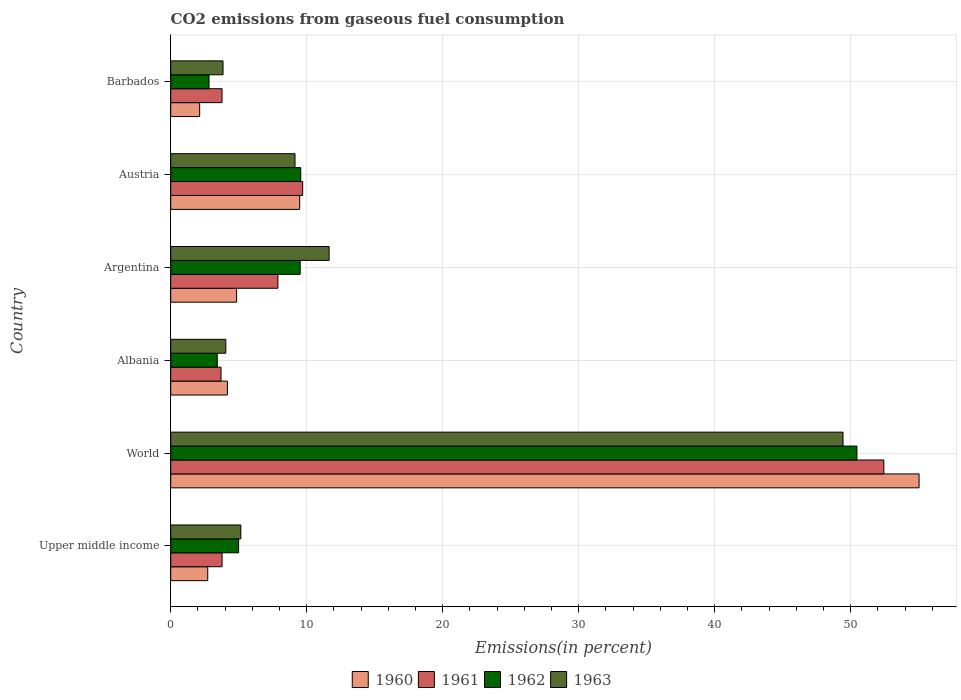How many different coloured bars are there?
Your answer should be compact. 4. Are the number of bars per tick equal to the number of legend labels?
Your response must be concise. Yes. Are the number of bars on each tick of the Y-axis equal?
Provide a succinct answer. Yes. What is the label of the 4th group of bars from the top?
Ensure brevity in your answer.  Albania. What is the total CO2 emitted in 1962 in World?
Provide a short and direct response. 50.46. Across all countries, what is the maximum total CO2 emitted in 1962?
Your answer should be compact. 50.46. Across all countries, what is the minimum total CO2 emitted in 1963?
Offer a very short reply. 3.85. In which country was the total CO2 emitted in 1961 maximum?
Provide a succinct answer. World. In which country was the total CO2 emitted in 1962 minimum?
Offer a terse response. Barbados. What is the total total CO2 emitted in 1960 in the graph?
Provide a short and direct response. 78.37. What is the difference between the total CO2 emitted in 1962 in Austria and that in Barbados?
Your answer should be very brief. 6.74. What is the difference between the total CO2 emitted in 1961 in World and the total CO2 emitted in 1962 in Upper middle income?
Give a very brief answer. 47.44. What is the average total CO2 emitted in 1961 per country?
Your response must be concise. 13.54. What is the difference between the total CO2 emitted in 1961 and total CO2 emitted in 1963 in Albania?
Provide a short and direct response. -0.35. What is the ratio of the total CO2 emitted in 1962 in Albania to that in Austria?
Provide a short and direct response. 0.36. Is the difference between the total CO2 emitted in 1961 in Albania and Argentina greater than the difference between the total CO2 emitted in 1963 in Albania and Argentina?
Your response must be concise. Yes. What is the difference between the highest and the second highest total CO2 emitted in 1961?
Provide a succinct answer. 42.73. What is the difference between the highest and the lowest total CO2 emitted in 1961?
Your response must be concise. 48.74. In how many countries, is the total CO2 emitted in 1960 greater than the average total CO2 emitted in 1960 taken over all countries?
Ensure brevity in your answer.  1. What does the 4th bar from the bottom in Upper middle income represents?
Ensure brevity in your answer.  1963. Does the graph contain grids?
Keep it short and to the point. Yes. What is the title of the graph?
Provide a short and direct response. CO2 emissions from gaseous fuel consumption. What is the label or title of the X-axis?
Provide a succinct answer. Emissions(in percent). What is the label or title of the Y-axis?
Your answer should be very brief. Country. What is the Emissions(in percent) in 1960 in Upper middle income?
Your response must be concise. 2.72. What is the Emissions(in percent) of 1961 in Upper middle income?
Ensure brevity in your answer.  3.78. What is the Emissions(in percent) in 1962 in Upper middle income?
Ensure brevity in your answer.  4.99. What is the Emissions(in percent) of 1963 in Upper middle income?
Provide a succinct answer. 5.15. What is the Emissions(in percent) in 1960 in World?
Offer a terse response. 55.02. What is the Emissions(in percent) in 1961 in World?
Your answer should be compact. 52.43. What is the Emissions(in percent) in 1962 in World?
Keep it short and to the point. 50.46. What is the Emissions(in percent) in 1963 in World?
Make the answer very short. 49.43. What is the Emissions(in percent) in 1960 in Albania?
Make the answer very short. 4.17. What is the Emissions(in percent) of 1961 in Albania?
Ensure brevity in your answer.  3.7. What is the Emissions(in percent) in 1962 in Albania?
Offer a terse response. 3.42. What is the Emissions(in percent) in 1963 in Albania?
Your response must be concise. 4.05. What is the Emissions(in percent) in 1960 in Argentina?
Provide a short and direct response. 4.85. What is the Emissions(in percent) of 1961 in Argentina?
Your response must be concise. 7.88. What is the Emissions(in percent) in 1962 in Argentina?
Offer a very short reply. 9.52. What is the Emissions(in percent) of 1963 in Argentina?
Your answer should be very brief. 11.65. What is the Emissions(in percent) of 1960 in Austria?
Provide a short and direct response. 9.48. What is the Emissions(in percent) of 1961 in Austria?
Your response must be concise. 9.7. What is the Emissions(in percent) in 1962 in Austria?
Provide a short and direct response. 9.56. What is the Emissions(in percent) in 1963 in Austria?
Provide a succinct answer. 9.14. What is the Emissions(in percent) of 1960 in Barbados?
Your answer should be compact. 2.13. What is the Emissions(in percent) in 1961 in Barbados?
Keep it short and to the point. 3.77. What is the Emissions(in percent) of 1962 in Barbados?
Provide a short and direct response. 2.82. What is the Emissions(in percent) of 1963 in Barbados?
Your response must be concise. 3.85. Across all countries, what is the maximum Emissions(in percent) in 1960?
Offer a terse response. 55.02. Across all countries, what is the maximum Emissions(in percent) of 1961?
Offer a very short reply. 52.43. Across all countries, what is the maximum Emissions(in percent) in 1962?
Provide a succinct answer. 50.46. Across all countries, what is the maximum Emissions(in percent) in 1963?
Give a very brief answer. 49.43. Across all countries, what is the minimum Emissions(in percent) of 1960?
Make the answer very short. 2.13. Across all countries, what is the minimum Emissions(in percent) in 1961?
Offer a very short reply. 3.7. Across all countries, what is the minimum Emissions(in percent) in 1962?
Your response must be concise. 2.82. Across all countries, what is the minimum Emissions(in percent) in 1963?
Give a very brief answer. 3.85. What is the total Emissions(in percent) in 1960 in the graph?
Keep it short and to the point. 78.37. What is the total Emissions(in percent) of 1961 in the graph?
Offer a terse response. 81.27. What is the total Emissions(in percent) in 1962 in the graph?
Give a very brief answer. 80.77. What is the total Emissions(in percent) of 1963 in the graph?
Make the answer very short. 83.27. What is the difference between the Emissions(in percent) of 1960 in Upper middle income and that in World?
Give a very brief answer. -52.3. What is the difference between the Emissions(in percent) of 1961 in Upper middle income and that in World?
Provide a succinct answer. -48.66. What is the difference between the Emissions(in percent) of 1962 in Upper middle income and that in World?
Provide a short and direct response. -45.46. What is the difference between the Emissions(in percent) in 1963 in Upper middle income and that in World?
Keep it short and to the point. -44.28. What is the difference between the Emissions(in percent) of 1960 in Upper middle income and that in Albania?
Provide a short and direct response. -1.44. What is the difference between the Emissions(in percent) in 1961 in Upper middle income and that in Albania?
Offer a terse response. 0.08. What is the difference between the Emissions(in percent) in 1962 in Upper middle income and that in Albania?
Your answer should be compact. 1.57. What is the difference between the Emissions(in percent) in 1963 in Upper middle income and that in Albania?
Your answer should be very brief. 1.11. What is the difference between the Emissions(in percent) of 1960 in Upper middle income and that in Argentina?
Offer a terse response. -2.12. What is the difference between the Emissions(in percent) in 1961 in Upper middle income and that in Argentina?
Ensure brevity in your answer.  -4.1. What is the difference between the Emissions(in percent) in 1962 in Upper middle income and that in Argentina?
Offer a very short reply. -4.53. What is the difference between the Emissions(in percent) of 1963 in Upper middle income and that in Argentina?
Provide a short and direct response. -6.49. What is the difference between the Emissions(in percent) in 1960 in Upper middle income and that in Austria?
Provide a short and direct response. -6.76. What is the difference between the Emissions(in percent) of 1961 in Upper middle income and that in Austria?
Offer a terse response. -5.92. What is the difference between the Emissions(in percent) of 1962 in Upper middle income and that in Austria?
Ensure brevity in your answer.  -4.57. What is the difference between the Emissions(in percent) in 1963 in Upper middle income and that in Austria?
Offer a terse response. -3.98. What is the difference between the Emissions(in percent) of 1960 in Upper middle income and that in Barbados?
Offer a terse response. 0.59. What is the difference between the Emissions(in percent) of 1961 in Upper middle income and that in Barbados?
Offer a very short reply. 0. What is the difference between the Emissions(in percent) in 1962 in Upper middle income and that in Barbados?
Provide a succinct answer. 2.18. What is the difference between the Emissions(in percent) in 1963 in Upper middle income and that in Barbados?
Your answer should be compact. 1.31. What is the difference between the Emissions(in percent) of 1960 in World and that in Albania?
Offer a terse response. 50.86. What is the difference between the Emissions(in percent) in 1961 in World and that in Albania?
Provide a succinct answer. 48.74. What is the difference between the Emissions(in percent) in 1962 in World and that in Albania?
Provide a short and direct response. 47.03. What is the difference between the Emissions(in percent) of 1963 in World and that in Albania?
Provide a short and direct response. 45.38. What is the difference between the Emissions(in percent) of 1960 in World and that in Argentina?
Ensure brevity in your answer.  50.18. What is the difference between the Emissions(in percent) of 1961 in World and that in Argentina?
Ensure brevity in your answer.  44.55. What is the difference between the Emissions(in percent) of 1962 in World and that in Argentina?
Your answer should be very brief. 40.94. What is the difference between the Emissions(in percent) in 1963 in World and that in Argentina?
Provide a succinct answer. 37.78. What is the difference between the Emissions(in percent) of 1960 in World and that in Austria?
Keep it short and to the point. 45.54. What is the difference between the Emissions(in percent) of 1961 in World and that in Austria?
Give a very brief answer. 42.73. What is the difference between the Emissions(in percent) in 1962 in World and that in Austria?
Give a very brief answer. 40.89. What is the difference between the Emissions(in percent) of 1963 in World and that in Austria?
Ensure brevity in your answer.  40.29. What is the difference between the Emissions(in percent) of 1960 in World and that in Barbados?
Provide a succinct answer. 52.9. What is the difference between the Emissions(in percent) in 1961 in World and that in Barbados?
Provide a short and direct response. 48.66. What is the difference between the Emissions(in percent) in 1962 in World and that in Barbados?
Give a very brief answer. 47.64. What is the difference between the Emissions(in percent) of 1963 in World and that in Barbados?
Your response must be concise. 45.59. What is the difference between the Emissions(in percent) in 1960 in Albania and that in Argentina?
Keep it short and to the point. -0.68. What is the difference between the Emissions(in percent) of 1961 in Albania and that in Argentina?
Provide a succinct answer. -4.18. What is the difference between the Emissions(in percent) in 1962 in Albania and that in Argentina?
Your answer should be compact. -6.1. What is the difference between the Emissions(in percent) of 1963 in Albania and that in Argentina?
Provide a short and direct response. -7.6. What is the difference between the Emissions(in percent) of 1960 in Albania and that in Austria?
Ensure brevity in your answer.  -5.32. What is the difference between the Emissions(in percent) in 1961 in Albania and that in Austria?
Ensure brevity in your answer.  -6. What is the difference between the Emissions(in percent) of 1962 in Albania and that in Austria?
Offer a very short reply. -6.14. What is the difference between the Emissions(in percent) of 1963 in Albania and that in Austria?
Provide a succinct answer. -5.09. What is the difference between the Emissions(in percent) in 1960 in Albania and that in Barbados?
Your answer should be compact. 2.04. What is the difference between the Emissions(in percent) of 1961 in Albania and that in Barbados?
Make the answer very short. -0.08. What is the difference between the Emissions(in percent) of 1962 in Albania and that in Barbados?
Your answer should be very brief. 0.61. What is the difference between the Emissions(in percent) of 1963 in Albania and that in Barbados?
Make the answer very short. 0.2. What is the difference between the Emissions(in percent) in 1960 in Argentina and that in Austria?
Offer a terse response. -4.64. What is the difference between the Emissions(in percent) of 1961 in Argentina and that in Austria?
Ensure brevity in your answer.  -1.82. What is the difference between the Emissions(in percent) of 1962 in Argentina and that in Austria?
Your answer should be very brief. -0.04. What is the difference between the Emissions(in percent) of 1963 in Argentina and that in Austria?
Your response must be concise. 2.51. What is the difference between the Emissions(in percent) in 1960 in Argentina and that in Barbados?
Make the answer very short. 2.72. What is the difference between the Emissions(in percent) of 1961 in Argentina and that in Barbados?
Keep it short and to the point. 4.11. What is the difference between the Emissions(in percent) of 1962 in Argentina and that in Barbados?
Give a very brief answer. 6.7. What is the difference between the Emissions(in percent) in 1963 in Argentina and that in Barbados?
Offer a terse response. 7.8. What is the difference between the Emissions(in percent) in 1960 in Austria and that in Barbados?
Offer a terse response. 7.35. What is the difference between the Emissions(in percent) of 1961 in Austria and that in Barbados?
Your response must be concise. 5.93. What is the difference between the Emissions(in percent) in 1962 in Austria and that in Barbados?
Make the answer very short. 6.74. What is the difference between the Emissions(in percent) of 1963 in Austria and that in Barbados?
Give a very brief answer. 5.29. What is the difference between the Emissions(in percent) of 1960 in Upper middle income and the Emissions(in percent) of 1961 in World?
Ensure brevity in your answer.  -49.71. What is the difference between the Emissions(in percent) in 1960 in Upper middle income and the Emissions(in percent) in 1962 in World?
Make the answer very short. -47.73. What is the difference between the Emissions(in percent) in 1960 in Upper middle income and the Emissions(in percent) in 1963 in World?
Your response must be concise. -46.71. What is the difference between the Emissions(in percent) of 1961 in Upper middle income and the Emissions(in percent) of 1962 in World?
Provide a succinct answer. -46.68. What is the difference between the Emissions(in percent) in 1961 in Upper middle income and the Emissions(in percent) in 1963 in World?
Your response must be concise. -45.66. What is the difference between the Emissions(in percent) of 1962 in Upper middle income and the Emissions(in percent) of 1963 in World?
Keep it short and to the point. -44.44. What is the difference between the Emissions(in percent) in 1960 in Upper middle income and the Emissions(in percent) in 1961 in Albania?
Ensure brevity in your answer.  -0.98. What is the difference between the Emissions(in percent) in 1960 in Upper middle income and the Emissions(in percent) in 1962 in Albania?
Make the answer very short. -0.7. What is the difference between the Emissions(in percent) in 1960 in Upper middle income and the Emissions(in percent) in 1963 in Albania?
Give a very brief answer. -1.33. What is the difference between the Emissions(in percent) of 1961 in Upper middle income and the Emissions(in percent) of 1962 in Albania?
Your answer should be very brief. 0.35. What is the difference between the Emissions(in percent) in 1961 in Upper middle income and the Emissions(in percent) in 1963 in Albania?
Ensure brevity in your answer.  -0.27. What is the difference between the Emissions(in percent) in 1962 in Upper middle income and the Emissions(in percent) in 1963 in Albania?
Keep it short and to the point. 0.94. What is the difference between the Emissions(in percent) in 1960 in Upper middle income and the Emissions(in percent) in 1961 in Argentina?
Your answer should be very brief. -5.16. What is the difference between the Emissions(in percent) in 1960 in Upper middle income and the Emissions(in percent) in 1962 in Argentina?
Provide a succinct answer. -6.8. What is the difference between the Emissions(in percent) in 1960 in Upper middle income and the Emissions(in percent) in 1963 in Argentina?
Your answer should be compact. -8.93. What is the difference between the Emissions(in percent) of 1961 in Upper middle income and the Emissions(in percent) of 1962 in Argentina?
Offer a very short reply. -5.74. What is the difference between the Emissions(in percent) in 1961 in Upper middle income and the Emissions(in percent) in 1963 in Argentina?
Offer a terse response. -7.87. What is the difference between the Emissions(in percent) in 1962 in Upper middle income and the Emissions(in percent) in 1963 in Argentina?
Provide a succinct answer. -6.66. What is the difference between the Emissions(in percent) in 1960 in Upper middle income and the Emissions(in percent) in 1961 in Austria?
Your response must be concise. -6.98. What is the difference between the Emissions(in percent) of 1960 in Upper middle income and the Emissions(in percent) of 1962 in Austria?
Offer a terse response. -6.84. What is the difference between the Emissions(in percent) in 1960 in Upper middle income and the Emissions(in percent) in 1963 in Austria?
Your answer should be very brief. -6.42. What is the difference between the Emissions(in percent) in 1961 in Upper middle income and the Emissions(in percent) in 1962 in Austria?
Give a very brief answer. -5.78. What is the difference between the Emissions(in percent) of 1961 in Upper middle income and the Emissions(in percent) of 1963 in Austria?
Your answer should be compact. -5.36. What is the difference between the Emissions(in percent) of 1962 in Upper middle income and the Emissions(in percent) of 1963 in Austria?
Provide a succinct answer. -4.15. What is the difference between the Emissions(in percent) of 1960 in Upper middle income and the Emissions(in percent) of 1961 in Barbados?
Your answer should be compact. -1.05. What is the difference between the Emissions(in percent) in 1960 in Upper middle income and the Emissions(in percent) in 1962 in Barbados?
Offer a very short reply. -0.1. What is the difference between the Emissions(in percent) of 1960 in Upper middle income and the Emissions(in percent) of 1963 in Barbados?
Provide a short and direct response. -1.12. What is the difference between the Emissions(in percent) of 1961 in Upper middle income and the Emissions(in percent) of 1962 in Barbados?
Ensure brevity in your answer.  0.96. What is the difference between the Emissions(in percent) of 1961 in Upper middle income and the Emissions(in percent) of 1963 in Barbados?
Make the answer very short. -0.07. What is the difference between the Emissions(in percent) of 1962 in Upper middle income and the Emissions(in percent) of 1963 in Barbados?
Offer a terse response. 1.15. What is the difference between the Emissions(in percent) in 1960 in World and the Emissions(in percent) in 1961 in Albania?
Offer a very short reply. 51.33. What is the difference between the Emissions(in percent) in 1960 in World and the Emissions(in percent) in 1962 in Albania?
Provide a succinct answer. 51.6. What is the difference between the Emissions(in percent) of 1960 in World and the Emissions(in percent) of 1963 in Albania?
Offer a very short reply. 50.98. What is the difference between the Emissions(in percent) of 1961 in World and the Emissions(in percent) of 1962 in Albania?
Keep it short and to the point. 49.01. What is the difference between the Emissions(in percent) of 1961 in World and the Emissions(in percent) of 1963 in Albania?
Ensure brevity in your answer.  48.38. What is the difference between the Emissions(in percent) of 1962 in World and the Emissions(in percent) of 1963 in Albania?
Keep it short and to the point. 46.41. What is the difference between the Emissions(in percent) of 1960 in World and the Emissions(in percent) of 1961 in Argentina?
Provide a succinct answer. 47.14. What is the difference between the Emissions(in percent) in 1960 in World and the Emissions(in percent) in 1962 in Argentina?
Your answer should be very brief. 45.5. What is the difference between the Emissions(in percent) of 1960 in World and the Emissions(in percent) of 1963 in Argentina?
Your answer should be very brief. 43.38. What is the difference between the Emissions(in percent) of 1961 in World and the Emissions(in percent) of 1962 in Argentina?
Keep it short and to the point. 42.91. What is the difference between the Emissions(in percent) in 1961 in World and the Emissions(in percent) in 1963 in Argentina?
Ensure brevity in your answer.  40.78. What is the difference between the Emissions(in percent) of 1962 in World and the Emissions(in percent) of 1963 in Argentina?
Offer a terse response. 38.81. What is the difference between the Emissions(in percent) in 1960 in World and the Emissions(in percent) in 1961 in Austria?
Ensure brevity in your answer.  45.32. What is the difference between the Emissions(in percent) of 1960 in World and the Emissions(in percent) of 1962 in Austria?
Provide a succinct answer. 45.46. What is the difference between the Emissions(in percent) of 1960 in World and the Emissions(in percent) of 1963 in Austria?
Give a very brief answer. 45.88. What is the difference between the Emissions(in percent) in 1961 in World and the Emissions(in percent) in 1962 in Austria?
Provide a succinct answer. 42.87. What is the difference between the Emissions(in percent) of 1961 in World and the Emissions(in percent) of 1963 in Austria?
Give a very brief answer. 43.29. What is the difference between the Emissions(in percent) of 1962 in World and the Emissions(in percent) of 1963 in Austria?
Provide a succinct answer. 41.32. What is the difference between the Emissions(in percent) in 1960 in World and the Emissions(in percent) in 1961 in Barbados?
Give a very brief answer. 51.25. What is the difference between the Emissions(in percent) of 1960 in World and the Emissions(in percent) of 1962 in Barbados?
Your answer should be compact. 52.21. What is the difference between the Emissions(in percent) of 1960 in World and the Emissions(in percent) of 1963 in Barbados?
Provide a succinct answer. 51.18. What is the difference between the Emissions(in percent) in 1961 in World and the Emissions(in percent) in 1962 in Barbados?
Give a very brief answer. 49.62. What is the difference between the Emissions(in percent) of 1961 in World and the Emissions(in percent) of 1963 in Barbados?
Give a very brief answer. 48.59. What is the difference between the Emissions(in percent) of 1962 in World and the Emissions(in percent) of 1963 in Barbados?
Make the answer very short. 46.61. What is the difference between the Emissions(in percent) of 1960 in Albania and the Emissions(in percent) of 1961 in Argentina?
Your answer should be very brief. -3.71. What is the difference between the Emissions(in percent) in 1960 in Albania and the Emissions(in percent) in 1962 in Argentina?
Ensure brevity in your answer.  -5.35. What is the difference between the Emissions(in percent) of 1960 in Albania and the Emissions(in percent) of 1963 in Argentina?
Make the answer very short. -7.48. What is the difference between the Emissions(in percent) of 1961 in Albania and the Emissions(in percent) of 1962 in Argentina?
Give a very brief answer. -5.82. What is the difference between the Emissions(in percent) in 1961 in Albania and the Emissions(in percent) in 1963 in Argentina?
Provide a short and direct response. -7.95. What is the difference between the Emissions(in percent) in 1962 in Albania and the Emissions(in percent) in 1963 in Argentina?
Your response must be concise. -8.23. What is the difference between the Emissions(in percent) in 1960 in Albania and the Emissions(in percent) in 1961 in Austria?
Provide a succinct answer. -5.54. What is the difference between the Emissions(in percent) in 1960 in Albania and the Emissions(in percent) in 1962 in Austria?
Give a very brief answer. -5.39. What is the difference between the Emissions(in percent) of 1960 in Albania and the Emissions(in percent) of 1963 in Austria?
Give a very brief answer. -4.97. What is the difference between the Emissions(in percent) in 1961 in Albania and the Emissions(in percent) in 1962 in Austria?
Ensure brevity in your answer.  -5.86. What is the difference between the Emissions(in percent) of 1961 in Albania and the Emissions(in percent) of 1963 in Austria?
Provide a succinct answer. -5.44. What is the difference between the Emissions(in percent) of 1962 in Albania and the Emissions(in percent) of 1963 in Austria?
Keep it short and to the point. -5.72. What is the difference between the Emissions(in percent) of 1960 in Albania and the Emissions(in percent) of 1961 in Barbados?
Offer a terse response. 0.39. What is the difference between the Emissions(in percent) in 1960 in Albania and the Emissions(in percent) in 1962 in Barbados?
Keep it short and to the point. 1.35. What is the difference between the Emissions(in percent) of 1960 in Albania and the Emissions(in percent) of 1963 in Barbados?
Provide a short and direct response. 0.32. What is the difference between the Emissions(in percent) of 1961 in Albania and the Emissions(in percent) of 1962 in Barbados?
Offer a very short reply. 0.88. What is the difference between the Emissions(in percent) in 1961 in Albania and the Emissions(in percent) in 1963 in Barbados?
Offer a very short reply. -0.15. What is the difference between the Emissions(in percent) in 1962 in Albania and the Emissions(in percent) in 1963 in Barbados?
Give a very brief answer. -0.42. What is the difference between the Emissions(in percent) of 1960 in Argentina and the Emissions(in percent) of 1961 in Austria?
Your answer should be compact. -4.86. What is the difference between the Emissions(in percent) of 1960 in Argentina and the Emissions(in percent) of 1962 in Austria?
Your response must be concise. -4.72. What is the difference between the Emissions(in percent) of 1960 in Argentina and the Emissions(in percent) of 1963 in Austria?
Your response must be concise. -4.29. What is the difference between the Emissions(in percent) in 1961 in Argentina and the Emissions(in percent) in 1962 in Austria?
Offer a very short reply. -1.68. What is the difference between the Emissions(in percent) in 1961 in Argentina and the Emissions(in percent) in 1963 in Austria?
Your response must be concise. -1.26. What is the difference between the Emissions(in percent) in 1962 in Argentina and the Emissions(in percent) in 1963 in Austria?
Give a very brief answer. 0.38. What is the difference between the Emissions(in percent) of 1960 in Argentina and the Emissions(in percent) of 1961 in Barbados?
Give a very brief answer. 1.07. What is the difference between the Emissions(in percent) in 1960 in Argentina and the Emissions(in percent) in 1962 in Barbados?
Keep it short and to the point. 2.03. What is the difference between the Emissions(in percent) of 1961 in Argentina and the Emissions(in percent) of 1962 in Barbados?
Provide a short and direct response. 5.06. What is the difference between the Emissions(in percent) of 1961 in Argentina and the Emissions(in percent) of 1963 in Barbados?
Provide a short and direct response. 4.04. What is the difference between the Emissions(in percent) in 1962 in Argentina and the Emissions(in percent) in 1963 in Barbados?
Provide a short and direct response. 5.67. What is the difference between the Emissions(in percent) in 1960 in Austria and the Emissions(in percent) in 1961 in Barbados?
Provide a succinct answer. 5.71. What is the difference between the Emissions(in percent) of 1960 in Austria and the Emissions(in percent) of 1962 in Barbados?
Your answer should be very brief. 6.67. What is the difference between the Emissions(in percent) in 1960 in Austria and the Emissions(in percent) in 1963 in Barbados?
Offer a very short reply. 5.64. What is the difference between the Emissions(in percent) of 1961 in Austria and the Emissions(in percent) of 1962 in Barbados?
Your response must be concise. 6.88. What is the difference between the Emissions(in percent) of 1961 in Austria and the Emissions(in percent) of 1963 in Barbados?
Offer a terse response. 5.86. What is the difference between the Emissions(in percent) of 1962 in Austria and the Emissions(in percent) of 1963 in Barbados?
Your answer should be very brief. 5.71. What is the average Emissions(in percent) in 1960 per country?
Your response must be concise. 13.06. What is the average Emissions(in percent) of 1961 per country?
Keep it short and to the point. 13.54. What is the average Emissions(in percent) in 1962 per country?
Keep it short and to the point. 13.46. What is the average Emissions(in percent) of 1963 per country?
Provide a short and direct response. 13.88. What is the difference between the Emissions(in percent) in 1960 and Emissions(in percent) in 1961 in Upper middle income?
Make the answer very short. -1.06. What is the difference between the Emissions(in percent) in 1960 and Emissions(in percent) in 1962 in Upper middle income?
Offer a very short reply. -2.27. What is the difference between the Emissions(in percent) of 1960 and Emissions(in percent) of 1963 in Upper middle income?
Your answer should be compact. -2.43. What is the difference between the Emissions(in percent) in 1961 and Emissions(in percent) in 1962 in Upper middle income?
Your response must be concise. -1.22. What is the difference between the Emissions(in percent) in 1961 and Emissions(in percent) in 1963 in Upper middle income?
Keep it short and to the point. -1.38. What is the difference between the Emissions(in percent) in 1962 and Emissions(in percent) in 1963 in Upper middle income?
Your answer should be compact. -0.16. What is the difference between the Emissions(in percent) in 1960 and Emissions(in percent) in 1961 in World?
Your response must be concise. 2.59. What is the difference between the Emissions(in percent) in 1960 and Emissions(in percent) in 1962 in World?
Ensure brevity in your answer.  4.57. What is the difference between the Emissions(in percent) in 1960 and Emissions(in percent) in 1963 in World?
Offer a very short reply. 5.59. What is the difference between the Emissions(in percent) of 1961 and Emissions(in percent) of 1962 in World?
Ensure brevity in your answer.  1.98. What is the difference between the Emissions(in percent) of 1961 and Emissions(in percent) of 1963 in World?
Keep it short and to the point. 3. What is the difference between the Emissions(in percent) in 1962 and Emissions(in percent) in 1963 in World?
Keep it short and to the point. 1.02. What is the difference between the Emissions(in percent) in 1960 and Emissions(in percent) in 1961 in Albania?
Your answer should be compact. 0.47. What is the difference between the Emissions(in percent) of 1960 and Emissions(in percent) of 1962 in Albania?
Your answer should be compact. 0.74. What is the difference between the Emissions(in percent) in 1960 and Emissions(in percent) in 1963 in Albania?
Offer a very short reply. 0.12. What is the difference between the Emissions(in percent) of 1961 and Emissions(in percent) of 1962 in Albania?
Offer a terse response. 0.28. What is the difference between the Emissions(in percent) in 1961 and Emissions(in percent) in 1963 in Albania?
Make the answer very short. -0.35. What is the difference between the Emissions(in percent) of 1962 and Emissions(in percent) of 1963 in Albania?
Your answer should be compact. -0.63. What is the difference between the Emissions(in percent) in 1960 and Emissions(in percent) in 1961 in Argentina?
Offer a very short reply. -3.04. What is the difference between the Emissions(in percent) of 1960 and Emissions(in percent) of 1962 in Argentina?
Give a very brief answer. -4.67. What is the difference between the Emissions(in percent) in 1960 and Emissions(in percent) in 1963 in Argentina?
Ensure brevity in your answer.  -6.8. What is the difference between the Emissions(in percent) of 1961 and Emissions(in percent) of 1962 in Argentina?
Keep it short and to the point. -1.64. What is the difference between the Emissions(in percent) in 1961 and Emissions(in percent) in 1963 in Argentina?
Your answer should be compact. -3.77. What is the difference between the Emissions(in percent) of 1962 and Emissions(in percent) of 1963 in Argentina?
Offer a terse response. -2.13. What is the difference between the Emissions(in percent) in 1960 and Emissions(in percent) in 1961 in Austria?
Your answer should be very brief. -0.22. What is the difference between the Emissions(in percent) of 1960 and Emissions(in percent) of 1962 in Austria?
Keep it short and to the point. -0.08. What is the difference between the Emissions(in percent) of 1960 and Emissions(in percent) of 1963 in Austria?
Offer a very short reply. 0.34. What is the difference between the Emissions(in percent) in 1961 and Emissions(in percent) in 1962 in Austria?
Provide a short and direct response. 0.14. What is the difference between the Emissions(in percent) of 1961 and Emissions(in percent) of 1963 in Austria?
Keep it short and to the point. 0.56. What is the difference between the Emissions(in percent) of 1962 and Emissions(in percent) of 1963 in Austria?
Give a very brief answer. 0.42. What is the difference between the Emissions(in percent) in 1960 and Emissions(in percent) in 1961 in Barbados?
Offer a terse response. -1.65. What is the difference between the Emissions(in percent) in 1960 and Emissions(in percent) in 1962 in Barbados?
Offer a very short reply. -0.69. What is the difference between the Emissions(in percent) of 1960 and Emissions(in percent) of 1963 in Barbados?
Ensure brevity in your answer.  -1.72. What is the difference between the Emissions(in percent) in 1961 and Emissions(in percent) in 1962 in Barbados?
Provide a succinct answer. 0.96. What is the difference between the Emissions(in percent) of 1961 and Emissions(in percent) of 1963 in Barbados?
Provide a succinct answer. -0.07. What is the difference between the Emissions(in percent) in 1962 and Emissions(in percent) in 1963 in Barbados?
Offer a very short reply. -1.03. What is the ratio of the Emissions(in percent) in 1960 in Upper middle income to that in World?
Ensure brevity in your answer.  0.05. What is the ratio of the Emissions(in percent) in 1961 in Upper middle income to that in World?
Offer a very short reply. 0.07. What is the ratio of the Emissions(in percent) in 1962 in Upper middle income to that in World?
Your answer should be very brief. 0.1. What is the ratio of the Emissions(in percent) in 1963 in Upper middle income to that in World?
Make the answer very short. 0.1. What is the ratio of the Emissions(in percent) of 1960 in Upper middle income to that in Albania?
Offer a very short reply. 0.65. What is the ratio of the Emissions(in percent) in 1961 in Upper middle income to that in Albania?
Give a very brief answer. 1.02. What is the ratio of the Emissions(in percent) in 1962 in Upper middle income to that in Albania?
Offer a terse response. 1.46. What is the ratio of the Emissions(in percent) of 1963 in Upper middle income to that in Albania?
Ensure brevity in your answer.  1.27. What is the ratio of the Emissions(in percent) in 1960 in Upper middle income to that in Argentina?
Provide a short and direct response. 0.56. What is the ratio of the Emissions(in percent) in 1961 in Upper middle income to that in Argentina?
Offer a terse response. 0.48. What is the ratio of the Emissions(in percent) in 1962 in Upper middle income to that in Argentina?
Keep it short and to the point. 0.52. What is the ratio of the Emissions(in percent) of 1963 in Upper middle income to that in Argentina?
Offer a very short reply. 0.44. What is the ratio of the Emissions(in percent) of 1960 in Upper middle income to that in Austria?
Keep it short and to the point. 0.29. What is the ratio of the Emissions(in percent) in 1961 in Upper middle income to that in Austria?
Your answer should be compact. 0.39. What is the ratio of the Emissions(in percent) of 1962 in Upper middle income to that in Austria?
Keep it short and to the point. 0.52. What is the ratio of the Emissions(in percent) in 1963 in Upper middle income to that in Austria?
Offer a terse response. 0.56. What is the ratio of the Emissions(in percent) in 1960 in Upper middle income to that in Barbados?
Make the answer very short. 1.28. What is the ratio of the Emissions(in percent) of 1962 in Upper middle income to that in Barbados?
Your answer should be very brief. 1.77. What is the ratio of the Emissions(in percent) in 1963 in Upper middle income to that in Barbados?
Give a very brief answer. 1.34. What is the ratio of the Emissions(in percent) in 1960 in World to that in Albania?
Offer a very short reply. 13.21. What is the ratio of the Emissions(in percent) in 1961 in World to that in Albania?
Keep it short and to the point. 14.18. What is the ratio of the Emissions(in percent) in 1962 in World to that in Albania?
Your answer should be compact. 14.74. What is the ratio of the Emissions(in percent) in 1963 in World to that in Albania?
Ensure brevity in your answer.  12.21. What is the ratio of the Emissions(in percent) of 1960 in World to that in Argentina?
Your answer should be compact. 11.36. What is the ratio of the Emissions(in percent) in 1961 in World to that in Argentina?
Keep it short and to the point. 6.65. What is the ratio of the Emissions(in percent) in 1962 in World to that in Argentina?
Provide a succinct answer. 5.3. What is the ratio of the Emissions(in percent) in 1963 in World to that in Argentina?
Give a very brief answer. 4.24. What is the ratio of the Emissions(in percent) of 1960 in World to that in Austria?
Provide a short and direct response. 5.8. What is the ratio of the Emissions(in percent) of 1961 in World to that in Austria?
Provide a short and direct response. 5.4. What is the ratio of the Emissions(in percent) in 1962 in World to that in Austria?
Ensure brevity in your answer.  5.28. What is the ratio of the Emissions(in percent) of 1963 in World to that in Austria?
Provide a short and direct response. 5.41. What is the ratio of the Emissions(in percent) of 1960 in World to that in Barbados?
Your answer should be very brief. 25.86. What is the ratio of the Emissions(in percent) in 1961 in World to that in Barbados?
Your response must be concise. 13.89. What is the ratio of the Emissions(in percent) of 1962 in World to that in Barbados?
Your answer should be compact. 17.91. What is the ratio of the Emissions(in percent) in 1963 in World to that in Barbados?
Give a very brief answer. 12.85. What is the ratio of the Emissions(in percent) in 1960 in Albania to that in Argentina?
Offer a terse response. 0.86. What is the ratio of the Emissions(in percent) in 1961 in Albania to that in Argentina?
Keep it short and to the point. 0.47. What is the ratio of the Emissions(in percent) of 1962 in Albania to that in Argentina?
Your answer should be very brief. 0.36. What is the ratio of the Emissions(in percent) of 1963 in Albania to that in Argentina?
Your answer should be compact. 0.35. What is the ratio of the Emissions(in percent) in 1960 in Albania to that in Austria?
Your answer should be compact. 0.44. What is the ratio of the Emissions(in percent) of 1961 in Albania to that in Austria?
Give a very brief answer. 0.38. What is the ratio of the Emissions(in percent) of 1962 in Albania to that in Austria?
Offer a very short reply. 0.36. What is the ratio of the Emissions(in percent) in 1963 in Albania to that in Austria?
Your answer should be compact. 0.44. What is the ratio of the Emissions(in percent) of 1960 in Albania to that in Barbados?
Keep it short and to the point. 1.96. What is the ratio of the Emissions(in percent) of 1961 in Albania to that in Barbados?
Give a very brief answer. 0.98. What is the ratio of the Emissions(in percent) of 1962 in Albania to that in Barbados?
Your answer should be very brief. 1.22. What is the ratio of the Emissions(in percent) in 1963 in Albania to that in Barbados?
Provide a short and direct response. 1.05. What is the ratio of the Emissions(in percent) of 1960 in Argentina to that in Austria?
Your response must be concise. 0.51. What is the ratio of the Emissions(in percent) in 1961 in Argentina to that in Austria?
Ensure brevity in your answer.  0.81. What is the ratio of the Emissions(in percent) in 1963 in Argentina to that in Austria?
Provide a succinct answer. 1.27. What is the ratio of the Emissions(in percent) in 1960 in Argentina to that in Barbados?
Keep it short and to the point. 2.28. What is the ratio of the Emissions(in percent) of 1961 in Argentina to that in Barbados?
Provide a short and direct response. 2.09. What is the ratio of the Emissions(in percent) in 1962 in Argentina to that in Barbados?
Offer a terse response. 3.38. What is the ratio of the Emissions(in percent) in 1963 in Argentina to that in Barbados?
Your answer should be very brief. 3.03. What is the ratio of the Emissions(in percent) in 1960 in Austria to that in Barbados?
Provide a succinct answer. 4.46. What is the ratio of the Emissions(in percent) in 1961 in Austria to that in Barbados?
Offer a very short reply. 2.57. What is the ratio of the Emissions(in percent) in 1962 in Austria to that in Barbados?
Offer a very short reply. 3.39. What is the ratio of the Emissions(in percent) of 1963 in Austria to that in Barbados?
Your response must be concise. 2.38. What is the difference between the highest and the second highest Emissions(in percent) in 1960?
Your answer should be compact. 45.54. What is the difference between the highest and the second highest Emissions(in percent) of 1961?
Give a very brief answer. 42.73. What is the difference between the highest and the second highest Emissions(in percent) in 1962?
Your answer should be very brief. 40.89. What is the difference between the highest and the second highest Emissions(in percent) in 1963?
Provide a succinct answer. 37.78. What is the difference between the highest and the lowest Emissions(in percent) in 1960?
Provide a short and direct response. 52.9. What is the difference between the highest and the lowest Emissions(in percent) of 1961?
Offer a terse response. 48.74. What is the difference between the highest and the lowest Emissions(in percent) of 1962?
Provide a short and direct response. 47.64. What is the difference between the highest and the lowest Emissions(in percent) in 1963?
Offer a terse response. 45.59. 